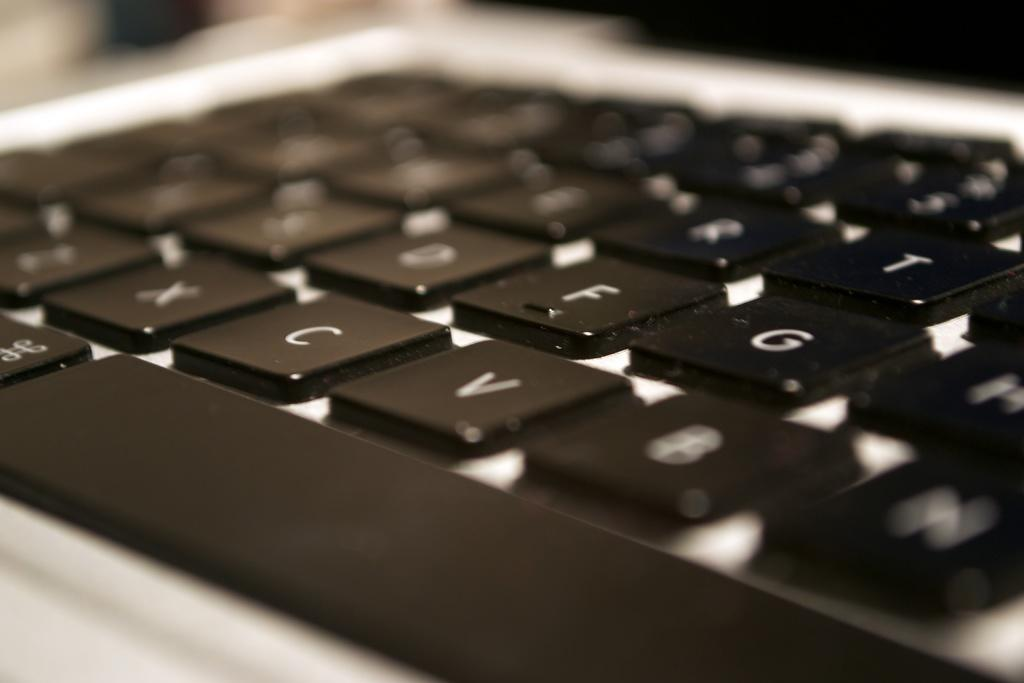<image>
Provide a brief description of the given image. A computer keyboard displays keys X, C and V, among others. 